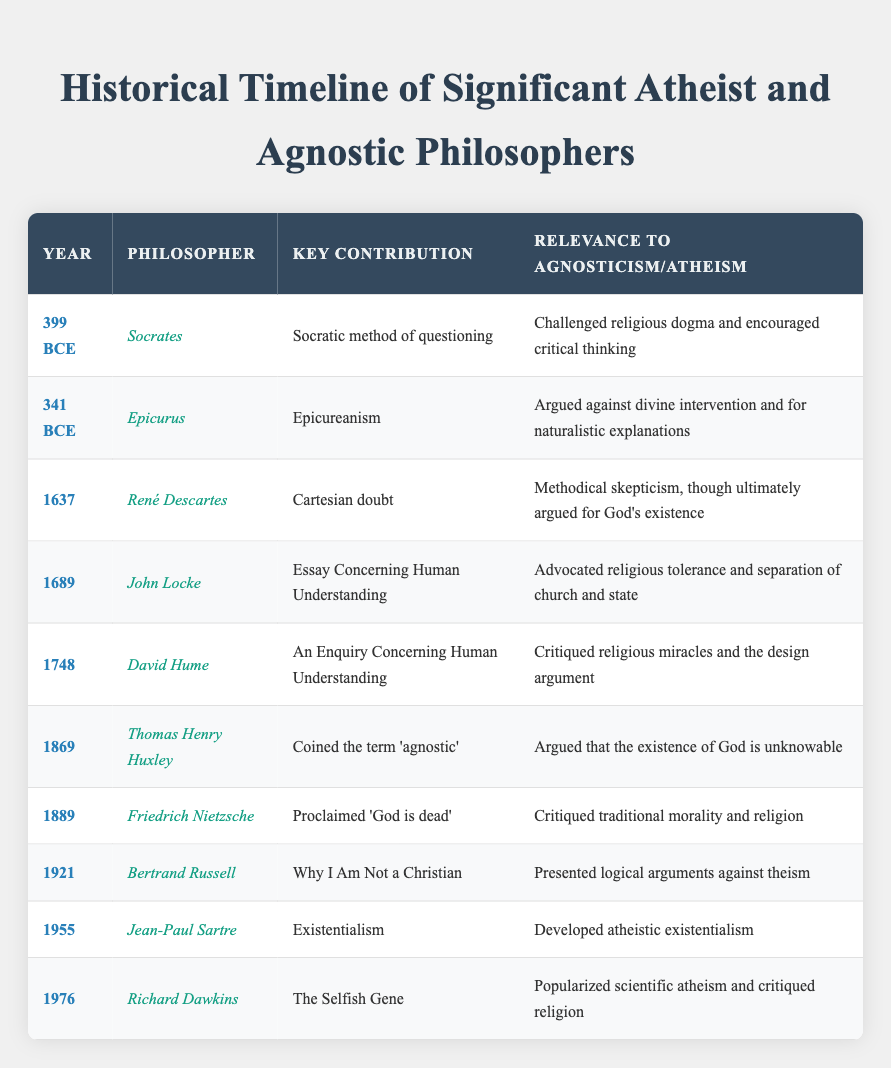What year did Socrates contribute to agnosticism or atheism? Socrates is listed in the row for the year 399 BCE, where his key contribution, the Socratic method of questioning, is associated with challenging religious dogma and encouraging critical thinking. Therefore, he contributed to the discourse on agnosticism and atheism in the year 399 BCE.
Answer: 399 BCE Who coined the term 'agnostic'? The row corresponding to the year 1869 lists Thomas Henry Huxley as the philosopher who coined the term 'agnostic'. This information is directly stated in the table, making it easy to retrieve.
Answer: Thomas Henry Huxley How many philosophers contributed to agnosticism or atheism before the 19th century? Analyzing the table, we find philosophers in 399 BCE (Socrates), 341 BCE (Epicurus), 1637 (René Descartes), 1689 (John Locke), 1748 (David Hume), and 1889 (Friedrich Nietzsche) before the 19th century. This results in a total of 5 philosophers before 1800, as Descartes, Locke, Hume, and Nietzsche are from the 17th and 18th centuries respectively.
Answer: 5 Did David Hume critique religious miracles? David Hume is indeed listed with the key contribution "An Enquiry Concerning Human Understanding," where it states he critiqued religious miracles and the design argument. Therefore, it is accurate to say he did critique religious miracles.
Answer: Yes Which philosopher is associated with the phrase "God is dead"? The table indicates that this phrase is attributed to Friedrich Nietzsche, who made this proclamation in the year 1889. The information is clear and directly linked to Nietzsche in the table.
Answer: Friedrich Nietzsche What is the average time period between the philosophers listed? To find the average time period between the contributions, the years provided should be transformed into a single-year sequence: 399 BCE, 341 BCE, 1637, 1689, 1748, 1869, 1889, 1921, 1955, and 1976. Calculating the time span between the earliest and latest dates gives a total range of 3375 years (from 399 BCE to 1976) and there are 10 contributions. To find the average spacing, we divide the total number of years (3375) by the number of gaps (9), resulting in an average period of about 375 years between each philosopher's contribution.
Answer: 375 years How many philosophers mentioned critiqued traditional morality and religion? The table shows that only Friedrich Nietzsche (1889) is noted for critiquing traditional morality and religion, which can be confirmed by reading the "Relevance" column associated with his entry. Thus, only one philosopher is credited with such critique.
Answer: 1 What was John Locke's main argument regarding religion? In the table, John Locke (1689) is known for his "Essay Concerning Human Understanding," advocating religious tolerance and separation of church and state, which are clearly indicated in the "Relevance" column.
Answer: Religious tolerance and separation of church and state What does the contribution of Richard Dawkins signify in terms of atheism? Richard Dawkins, noted in 1976 for "The Selfish Gene," emphasized the popularity of scientific atheism and critiqued religion. This signifies a shift towards a more evidence-based approach to atheism that emerged in the late 20th century, as indicated in the relevance provided.
Answer: Popularized scientific atheism and critiqued religion 